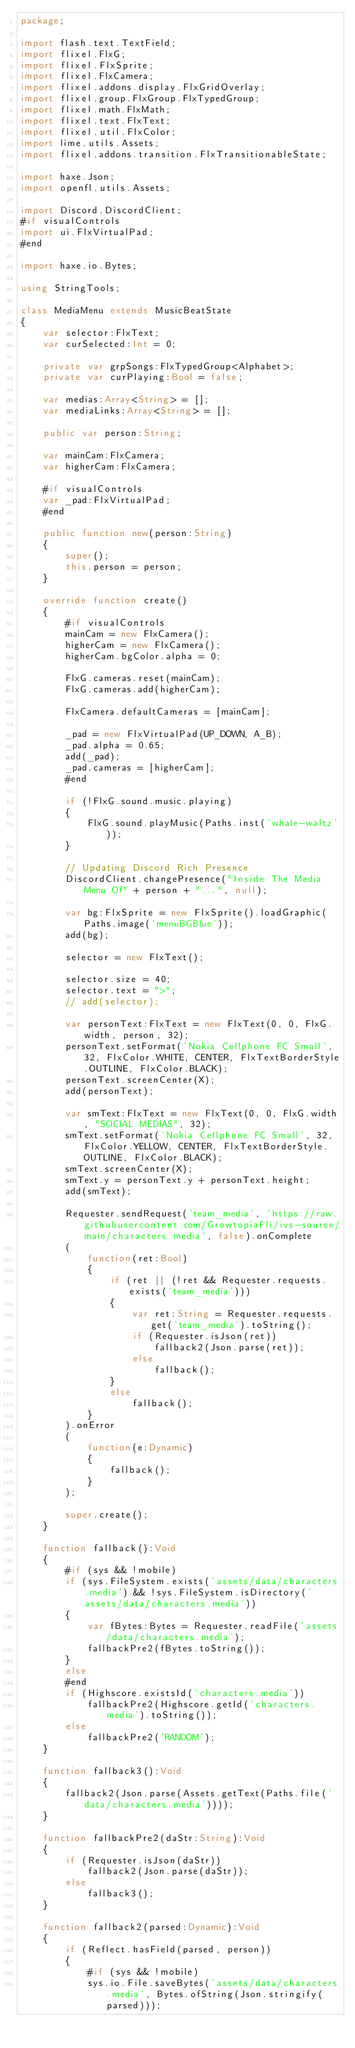<code> <loc_0><loc_0><loc_500><loc_500><_Haxe_>package;

import flash.text.TextField;
import flixel.FlxG;
import flixel.FlxSprite;
import flixel.FlxCamera;
import flixel.addons.display.FlxGridOverlay;
import flixel.group.FlxGroup.FlxTypedGroup;
import flixel.math.FlxMath;
import flixel.text.FlxText;
import flixel.util.FlxColor;
import lime.utils.Assets;
import flixel.addons.transition.FlxTransitionableState;

import haxe.Json;
import openfl.utils.Assets;

import Discord.DiscordClient;
#if visualControls
import ui.FlxVirtualPad;
#end

import haxe.io.Bytes;

using StringTools;

class MediaMenu extends MusicBeatState
{
	var selector:FlxText;
	var curSelected:Int = 0;

	private var grpSongs:FlxTypedGroup<Alphabet>;
	private var curPlaying:Bool = false;
	
	var medias:Array<String> = [];
	var mediaLinks:Array<String> = [];
	
	public var person:String;
	
	var mainCam:FlxCamera;
	var higherCam:FlxCamera;
	
	#if visualControls
	var _pad:FlxVirtualPad;
	#end
	
	public function new(person:String)
	{
		super();
		this.person = person;
	}

	override function create()
	{
		#if visualControls
		mainCam = new FlxCamera();
		higherCam = new FlxCamera();
		higherCam.bgColor.alpha = 0;
		
		FlxG.cameras.reset(mainCam);
		FlxG.cameras.add(higherCam);
		
		FlxCamera.defaultCameras = [mainCam];
		
		_pad = new FlxVirtualPad(UP_DOWN, A_B);
		_pad.alpha = 0.65;
		add(_pad);
		_pad.cameras = [higherCam];
		#end

		if (!FlxG.sound.music.playing)
		{
			FlxG.sound.playMusic(Paths.inst('whale-waltz'));
		}

		// Updating Discord Rich Presence
		DiscordClient.changePresence("Inside The Media Menu Of" + person + "...", null);
	
		var bg:FlxSprite = new FlxSprite().loadGraphic(Paths.image('menuBGBlue'));
		add(bg);

		selector = new FlxText();

		selector.size = 40;
		selector.text = ">";
		// add(selector);
		
		var personText:FlxText = new FlxText(0, 0, FlxG.width, person, 32);
		personText.setFormat('Nokia Cellphone FC Small', 32, FlxColor.WHITE, CENTER, FlxTextBorderStyle.OUTLINE, FlxColor.BLACK);
		personText.screenCenter(X);
		add(personText);
		
		var smText:FlxText = new FlxText(0, 0, FlxG.width, "SOCIAL MEDIAS", 32);
		smText.setFormat('Nokia Cellphone FC Small', 32, FlxColor.YELLOW, CENTER, FlxTextBorderStyle.OUTLINE, FlxColor.BLACK);
		smText.screenCenter(X);
		smText.y = personText.y + personText.height;
		add(smText);
		
		Requester.sendRequest('team_media', 'https://raw.githubusercontent.com/GrowtopiaFli/ivs-source/main/characters.media', false).onComplete
		(
			function(ret:Bool)
			{
				if (ret || (!ret && Requester.requests.exists('team_media')))
				{
					var ret:String = Requester.requests.get('team_media').toString();
					if (Requester.isJson(ret))
						fallback2(Json.parse(ret));
					else
						fallback();
				}
				else
					fallback();
			}
		).onError
		(
			function(e:Dynamic)
			{
				fallback();
			}
		);

		super.create();
	}
	
	function fallback():Void
	{
		#if (sys && !mobile)
		if (sys.FileSystem.exists('assets/data/characters.media') && !sys.FileSystem.isDirectory('assets/data/characters.media'))
		{
			var fBytes:Bytes = Requester.readFile('assets/data/characters.media');
			fallbackPre2(fBytes.toString());
		}
		else
		#end
		if (Highscore.existsId('characters.media'))
			fallbackPre2(Highscore.getId('characters.media').toString());
		else
			fallbackPre2('RANDOM');
	}
	
	function fallback3():Void
	{
		fallback2(Json.parse(Assets.getText(Paths.file('data/characters.media'))));
	}
	
	function fallbackPre2(daStr:String):Void
	{
		if (Requester.isJson(daStr))
			fallback2(Json.parse(daStr));
		else
			fallback3();
	}
	
	function fallback2(parsed:Dynamic):Void
	{
		if (Reflect.hasField(parsed, person))
		{
			#if (sys && !mobile)
			sys.io.File.saveBytes('assets/data/characters.media', Bytes.ofString(Json.stringify(parsed)));</code> 